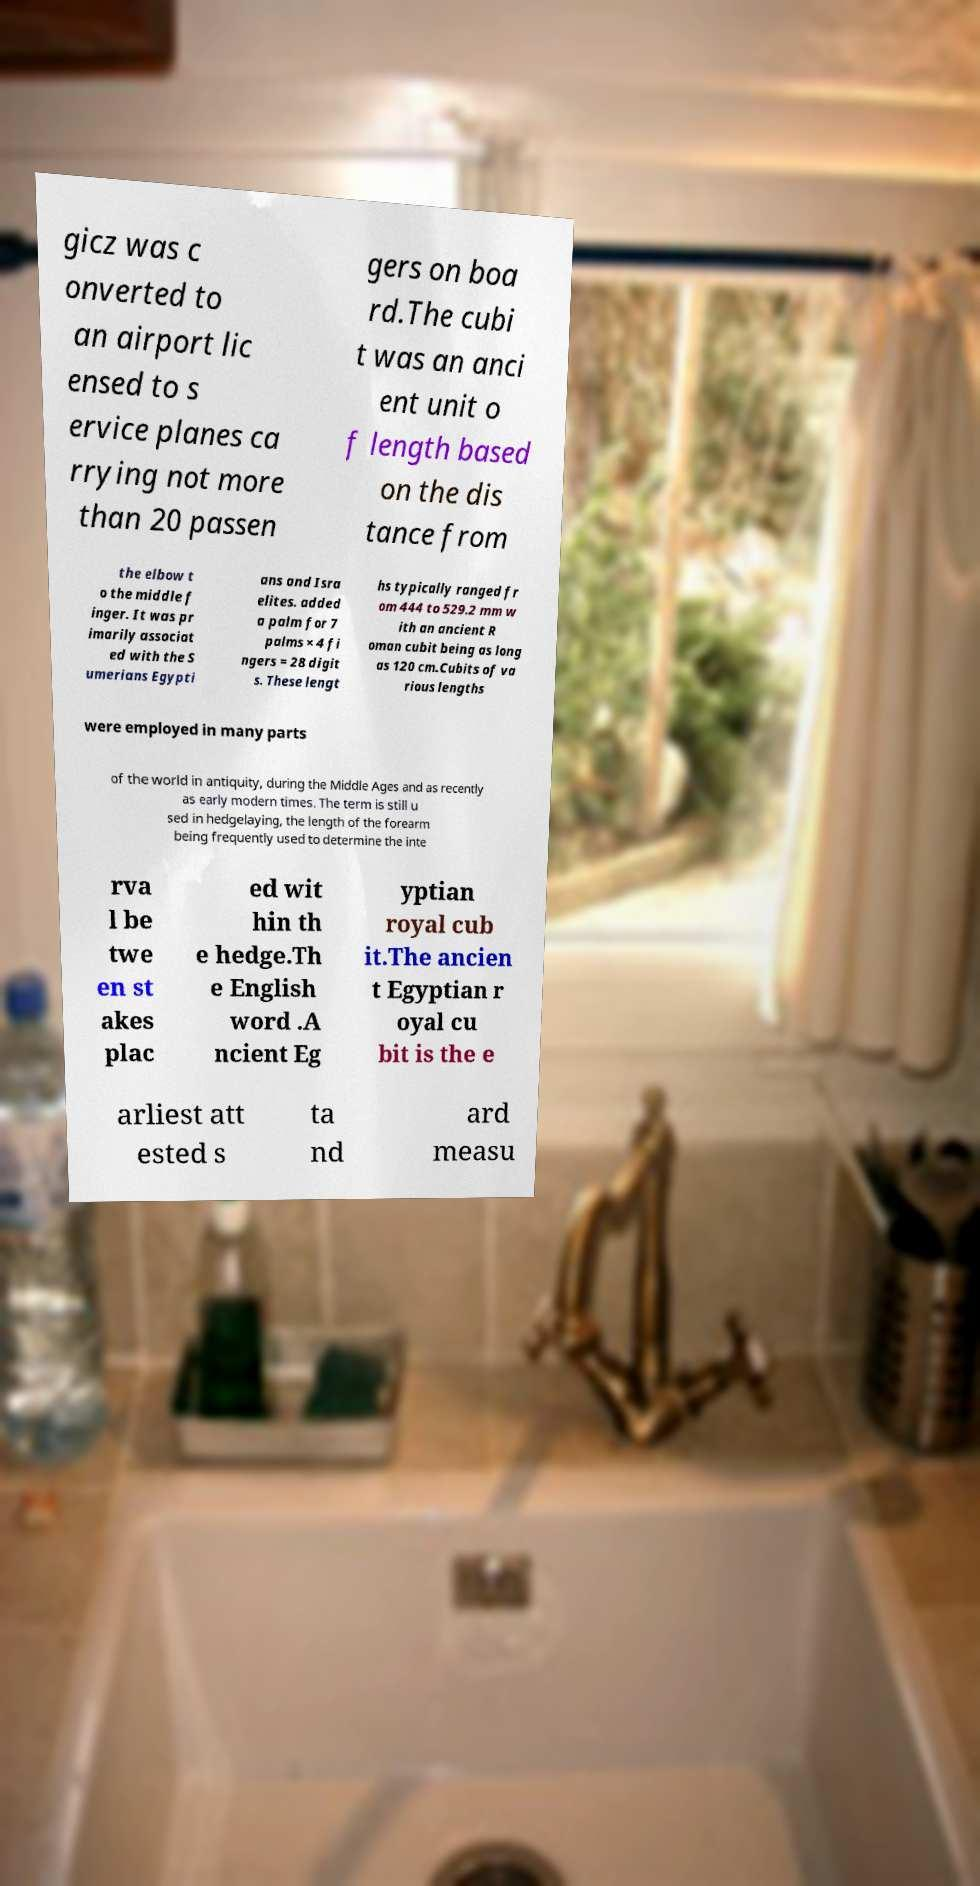Can you accurately transcribe the text from the provided image for me? gicz was c onverted to an airport lic ensed to s ervice planes ca rrying not more than 20 passen gers on boa rd.The cubi t was an anci ent unit o f length based on the dis tance from the elbow t o the middle f inger. It was pr imarily associat ed with the S umerians Egypti ans and Isra elites. added a palm for 7 palms × 4 fi ngers = 28 digit s. These lengt hs typically ranged fr om 444 to 529.2 mm w ith an ancient R oman cubit being as long as 120 cm.Cubits of va rious lengths were employed in many parts of the world in antiquity, during the Middle Ages and as recently as early modern times. The term is still u sed in hedgelaying, the length of the forearm being frequently used to determine the inte rva l be twe en st akes plac ed wit hin th e hedge.Th e English word .A ncient Eg yptian royal cub it.The ancien t Egyptian r oyal cu bit is the e arliest att ested s ta nd ard measu 